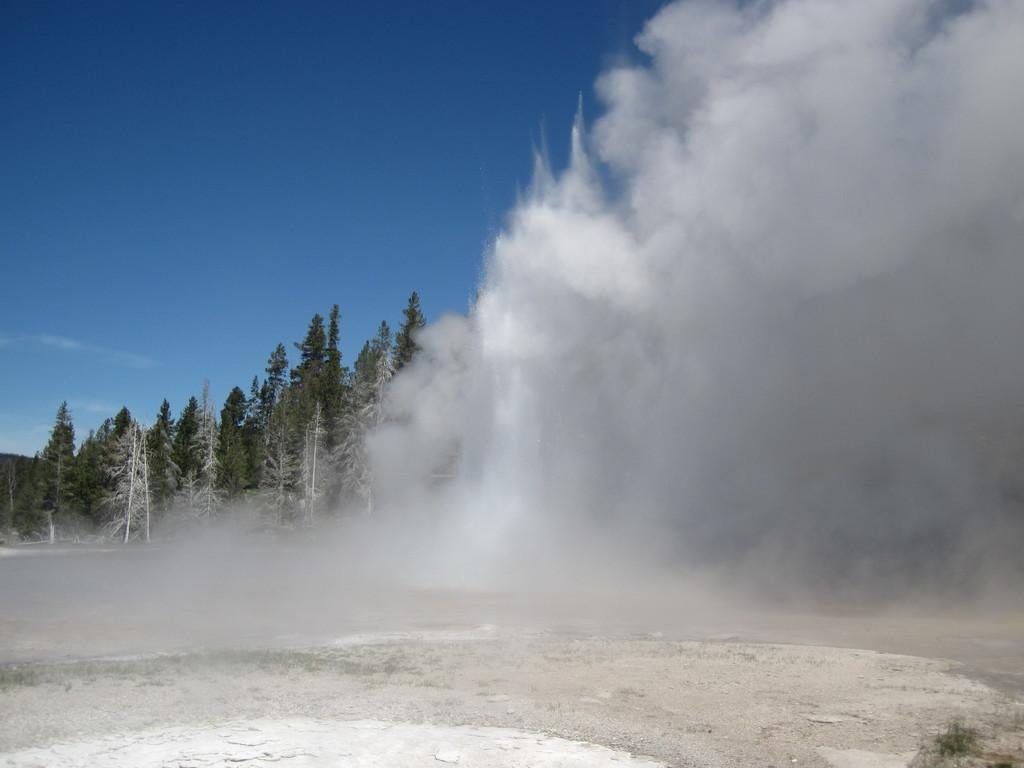What can be seen at the bottom of the image? The ground is visible in the image. What natural phenomenon is occurring in the image? There is a dust storm in the image. What type of vegetation is present in the image? There are trees in the image. What is visible in the distance in the image? The sky is visible in the background of the image. What type of brush is being used to paint the watch in the image? There is no brush or watch present in the image; it features a dust storm and trees. 